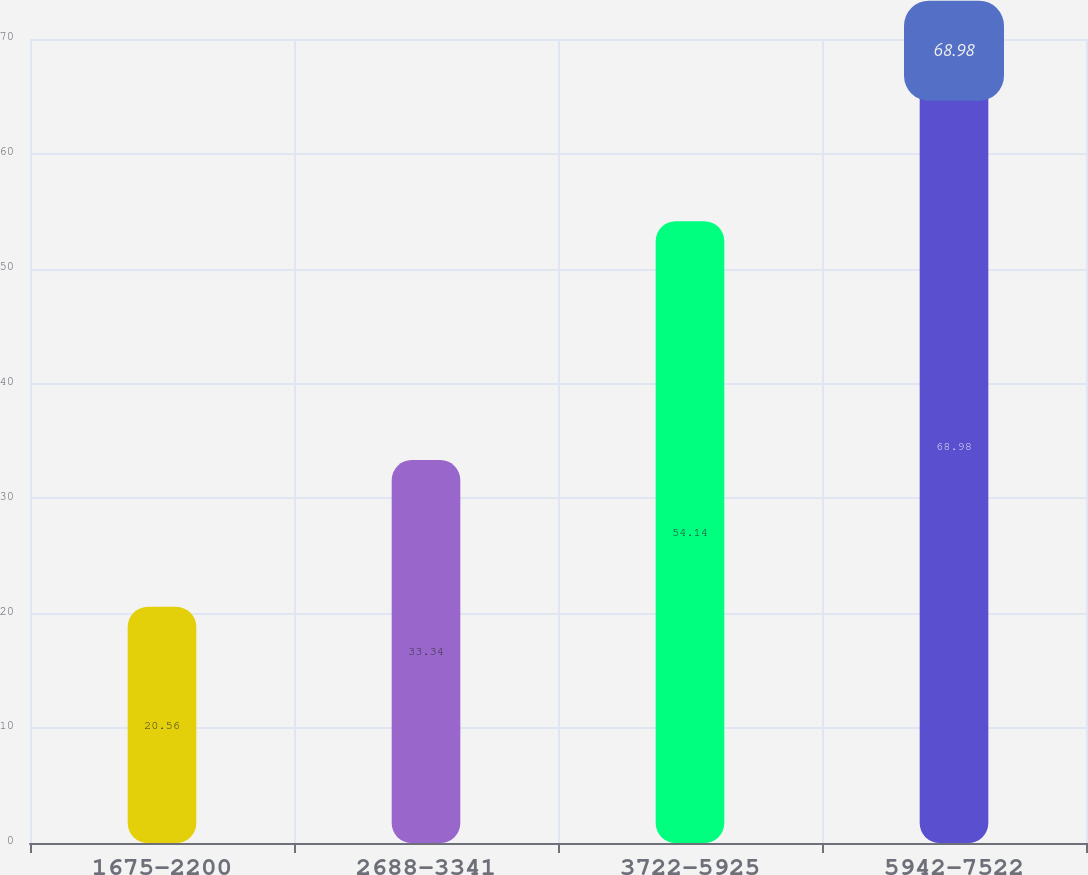Convert chart. <chart><loc_0><loc_0><loc_500><loc_500><bar_chart><fcel>1675-2200<fcel>2688-3341<fcel>3722-5925<fcel>5942-7522<nl><fcel>20.56<fcel>33.34<fcel>54.14<fcel>68.98<nl></chart> 